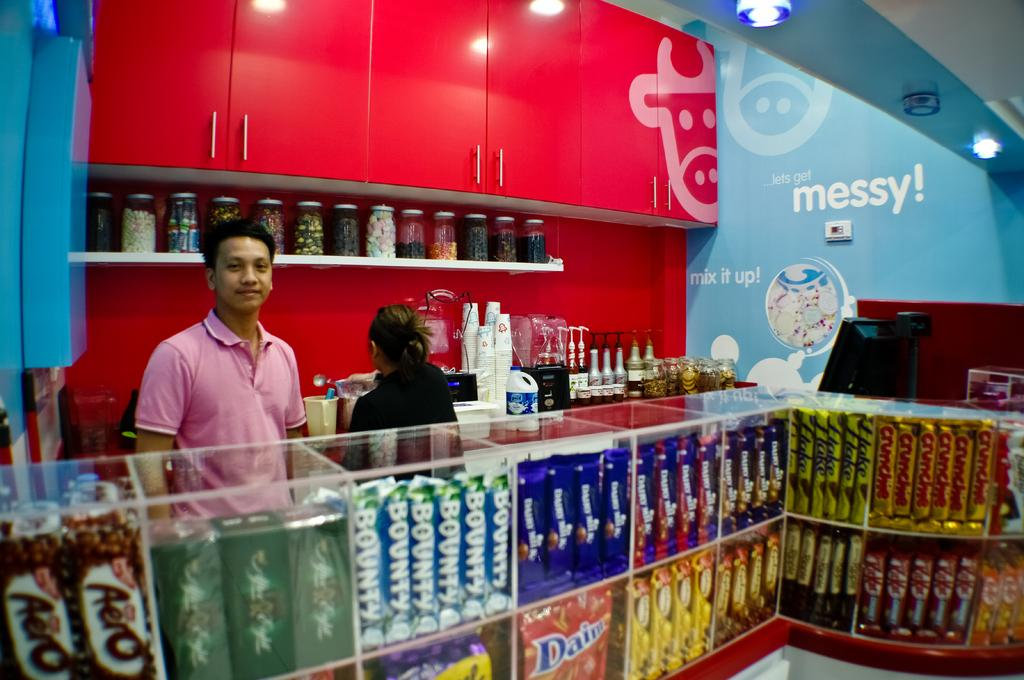<image>
Provide a brief description of the given image. a shelf of candy bars and chips with things like bounty and flake 